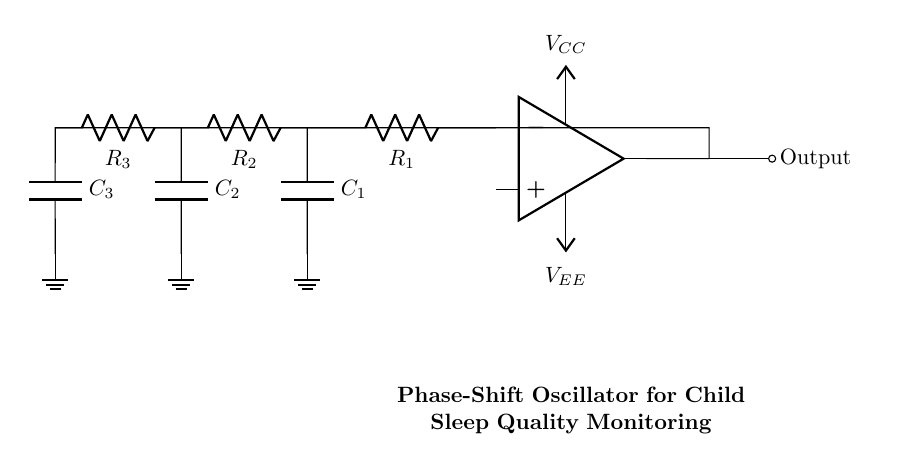What are the key components in this oscillator circuit? The key components are the operational amplifier, resistors, and capacitors. The circuit prominently features an op-amp as the main component, along with three resistors and three capacitors arranged in an RC network contributing to the phase shift necessary for oscillation.
Answer: operational amplifier, resistors, capacitors What is the role of the operational amplifier in this circuit? The operational amplifier serves as the active component that amplifies the signal while maintaining the necessary conditions for oscillation. It takes the output signal and feeds it back to the input in combination with the phase-shifting elements, ensuring that the output oscillates at a consistent frequency.
Answer: amplifies the signal How many resistors are present in the circuit? There are three resistors in the circuit. They are labeled as R1, R2, and R3 and play a critical role in forming the RC feedback loop required for generating the oscillations.
Answer: three What is the purpose of the phase shift in this oscillator? The phase shift is crucial for generating a sinusoidal waveform, as it ensures that the total phase of the signal returning to the input of the op-amp is exactly 360 degrees, allowing for continuous oscillation. The specific arrangement of resistors and capacitors determines the amount of phase shift achieved.
Answer: to generate a sinusoidal waveform What type of feedback is utilized in this oscillator circuit? The circuit uses negative feedback. This feedback helps stabilize the oscillations by feeding back a portion of the output signal, which adjusts the input in such a way as to control the amplitude and frequency of the oscillation effectively.
Answer: negative feedback How does the circuit generate its output waveform? The circuit generates its output waveform through the interaction between the resistors and capacitors, which creates a phase shift, and the operational amplifier, which amplifies the resulting signal. The interplay between charging and discharging of capacitors with the resistors creates the sinusoidal output that is essential for sleep quality monitoring.
Answer: through phase shift and amplification 